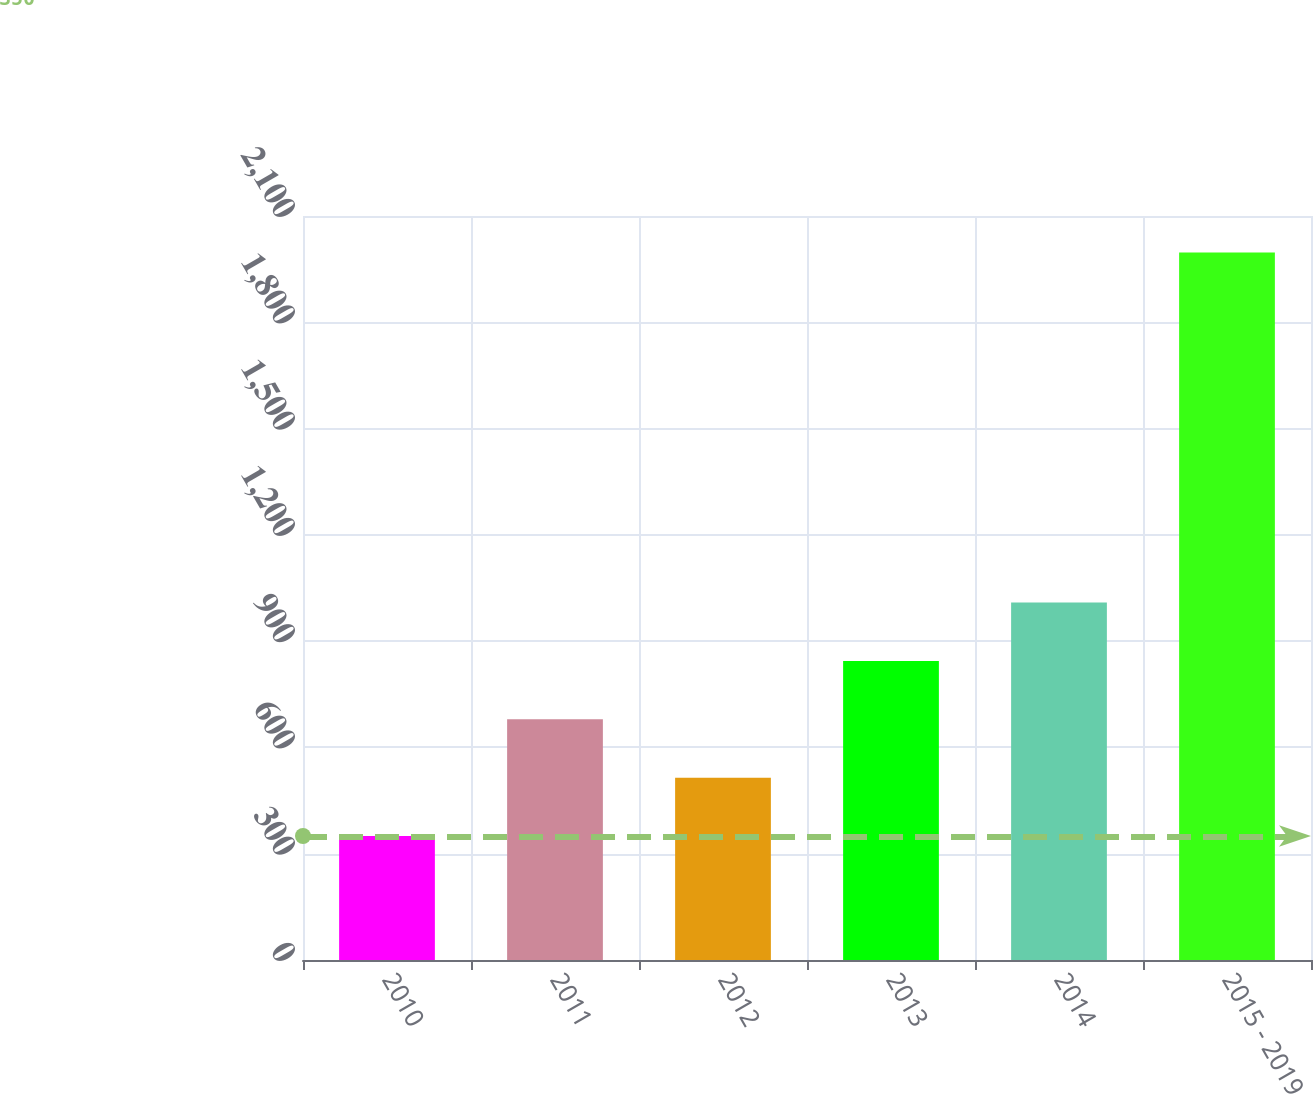Convert chart to OTSL. <chart><loc_0><loc_0><loc_500><loc_500><bar_chart><fcel>2010<fcel>2011<fcel>2012<fcel>2013<fcel>2014<fcel>2015 - 2019<nl><fcel>350<fcel>679.4<fcel>514.7<fcel>844.1<fcel>1008.8<fcel>1997<nl></chart> 